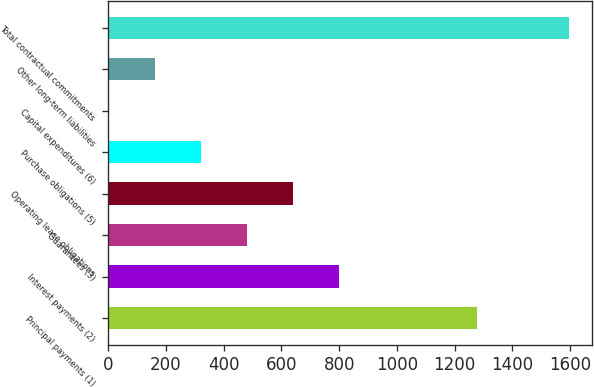Convert chart. <chart><loc_0><loc_0><loc_500><loc_500><bar_chart><fcel>Principal payments (1)<fcel>Interest payments (2)<fcel>Guarantees (3)<fcel>Operating lease obligations<fcel>Purchase obligations (5)<fcel>Capital expenditures (6)<fcel>Other long-term liabilities<fcel>Total contractual commitments<nl><fcel>1277<fcel>800.44<fcel>481.81<fcel>641.12<fcel>322.49<fcel>3.85<fcel>163.17<fcel>1597<nl></chart> 